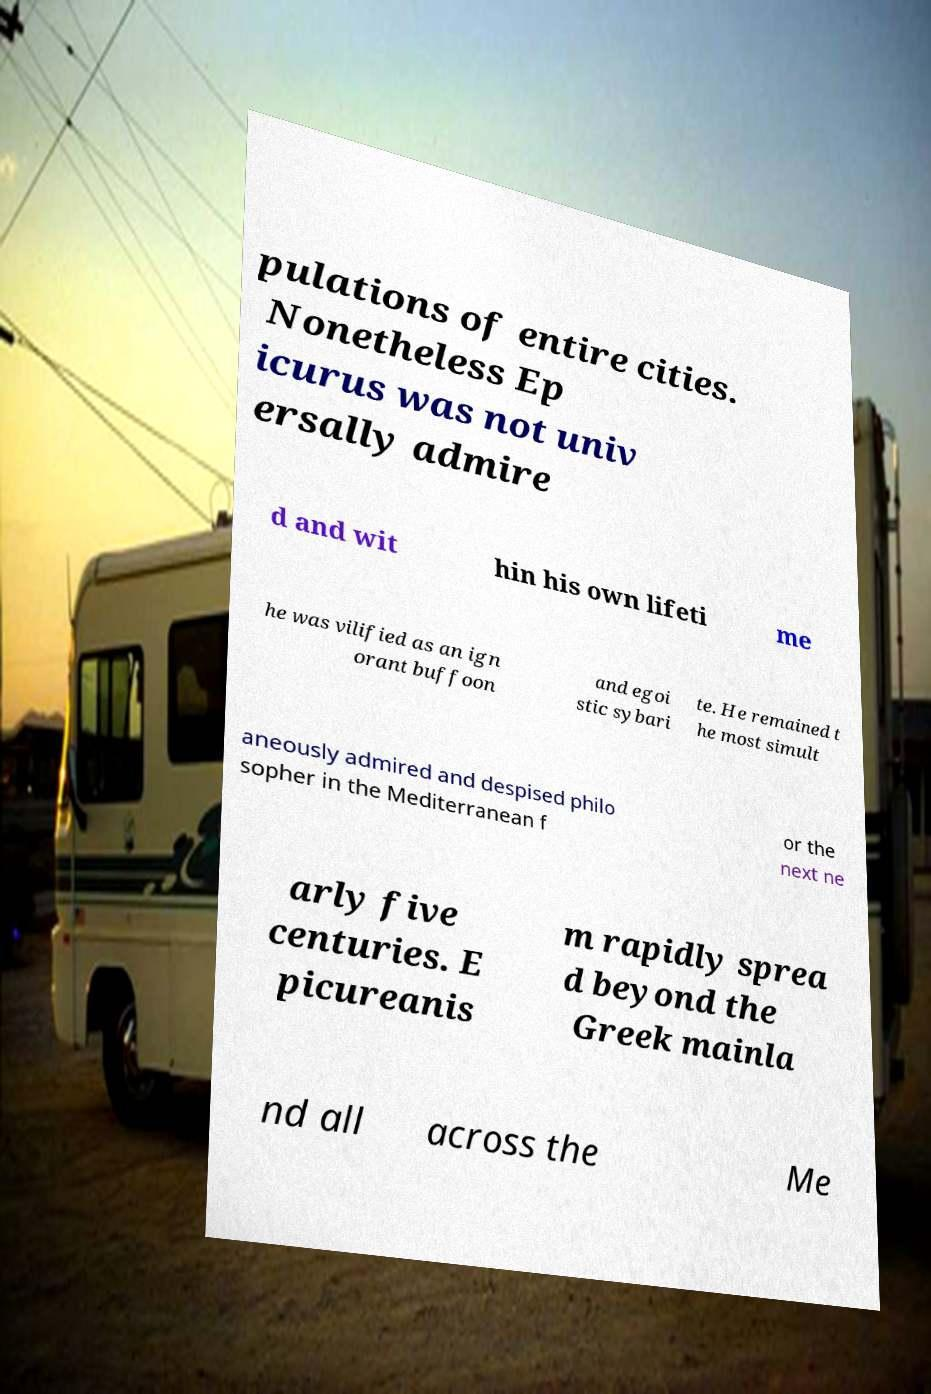I need the written content from this picture converted into text. Can you do that? pulations of entire cities. Nonetheless Ep icurus was not univ ersally admire d and wit hin his own lifeti me he was vilified as an ign orant buffoon and egoi stic sybari te. He remained t he most simult aneously admired and despised philo sopher in the Mediterranean f or the next ne arly five centuries. E picureanis m rapidly sprea d beyond the Greek mainla nd all across the Me 